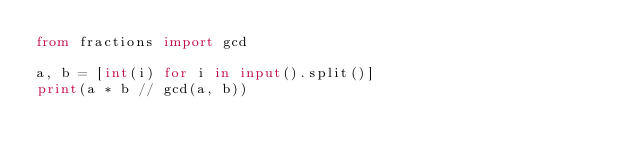<code> <loc_0><loc_0><loc_500><loc_500><_Python_>from fractions import gcd

a, b = [int(i) for i in input().split()]
print(a * b // gcd(a, b))</code> 